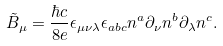<formula> <loc_0><loc_0><loc_500><loc_500>\tilde { B } _ { \mu } = \frac { \hbar { c } } { 8 e } \epsilon _ { \mu \nu \lambda } \epsilon _ { a b c } n ^ { a } \partial _ { \nu } n ^ { b } \partial _ { \lambda } n ^ { c } .</formula> 